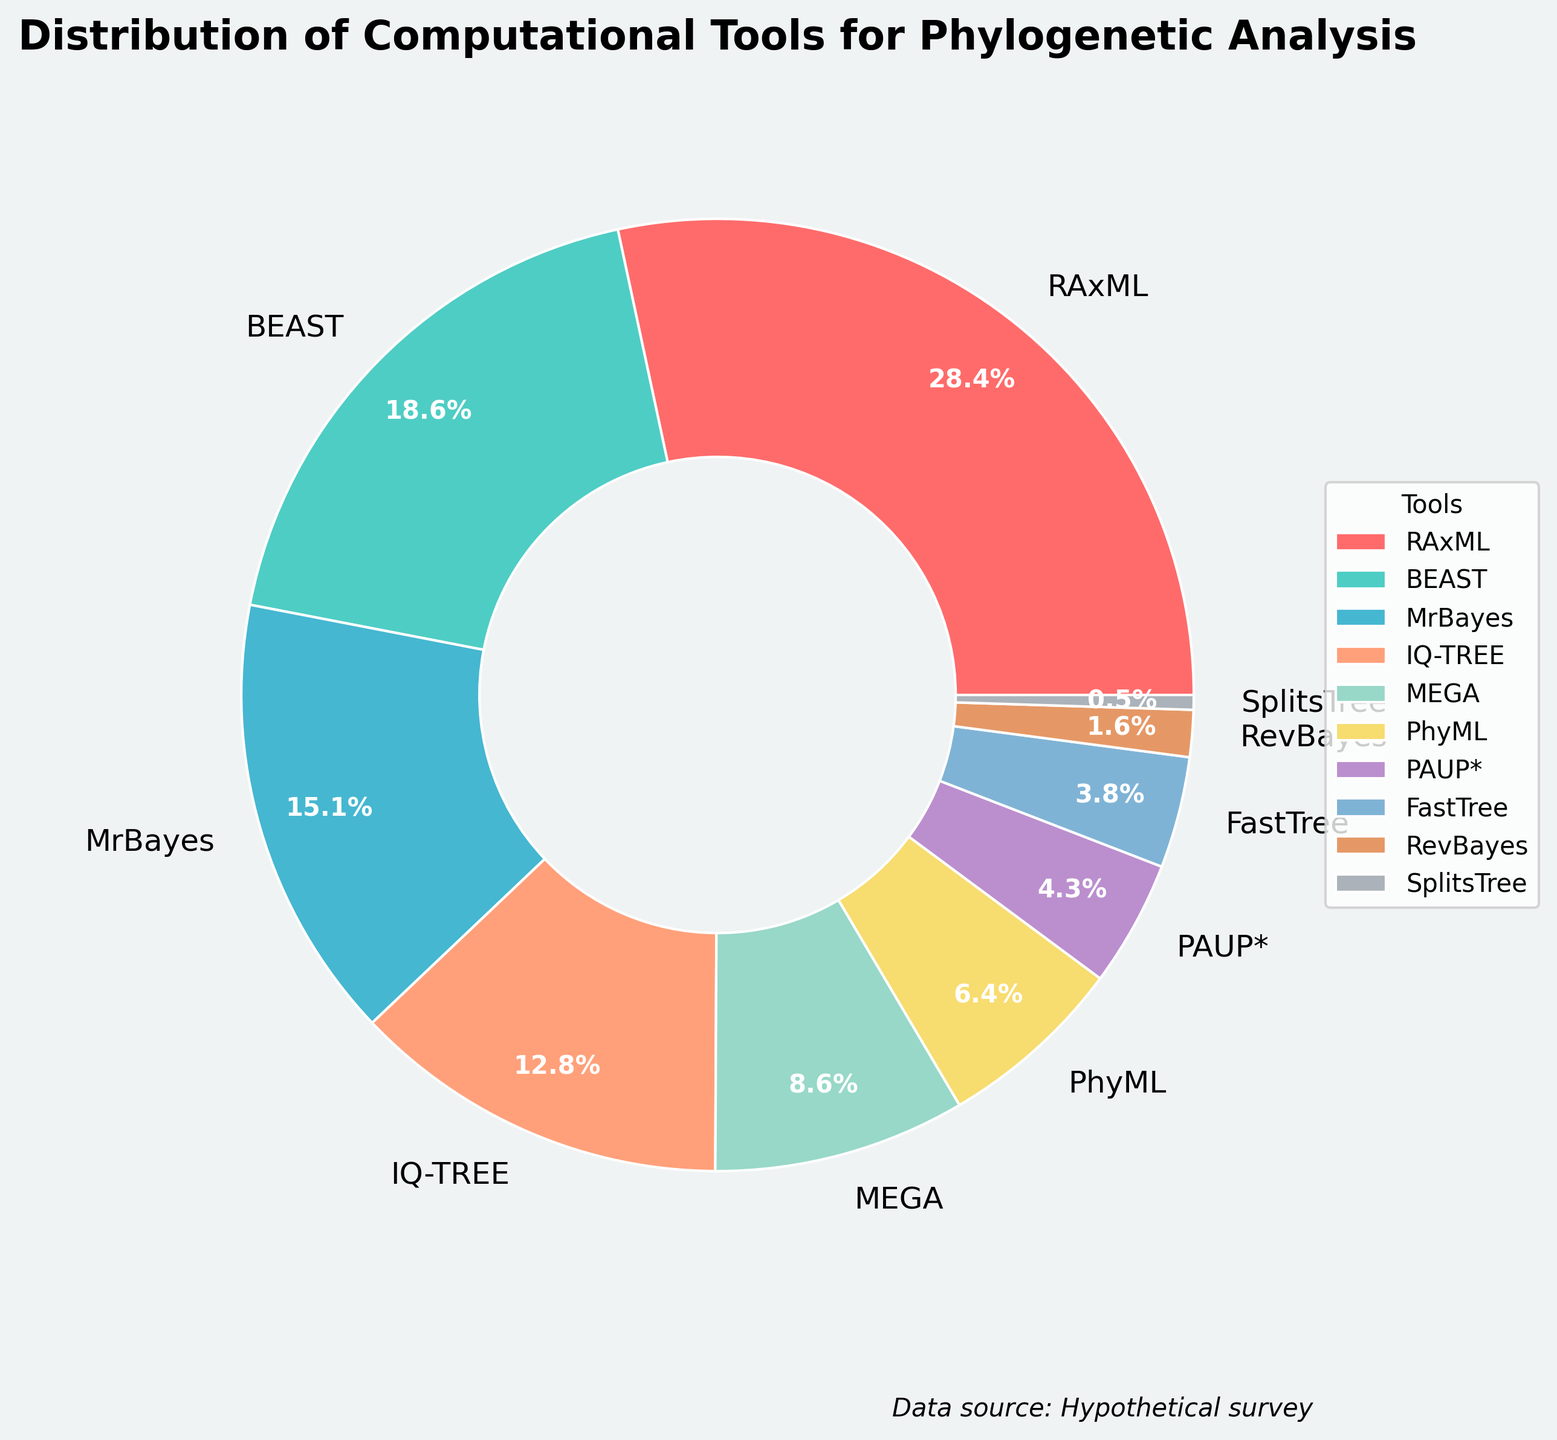Which tool has the highest usage percentage? The pie chart shows the usage percentages of different computational tools. By observing the largest section, we see that RAxML has the highest usage percentage.
Answer: RAxML What is the combined usage percentage of BEAST and MrBayes? We need to sum the usage percentages of BEAST and MrBayes. BEAST has 18.7% and MrBayes has 15.2%. Adding these together gives 18.7 + 15.2 = 33.9%.
Answer: 33.9% Which tool has the lowest usage percentage? The smallest section of the pie chart represents the tool with the lowest usage percentage. SplitsTree occupies the smallest section.
Answer: SplitsTree Are there any tools with similar usage percentages? By comparing the sections of the pie chart, we can see which tools have similar sizes. IQ-TREE and MEGA have similar usage percentages (12.9% and 8.6%, respectively), but upon closer inspection, they are not very close. PhyML and PAUP*, however, are closer (6.4% and 4.3%).
Answer: PhyML and PAUP* What is the difference in usage percentage between IQ-TREE and MEGA? We need to subtract the usage percentage of MEGA from that of IQ-TREE. IQ-TREE has 12.9% and MEGA has 8.6%. So, 12.9% - 8.6% = 4.3%.
Answer: 4.3% Between RAxML and FastTree, which tool is used less and by how much? RAxML has a usage percentage of 28.5% and FastTree has 3.8%. The difference is 28.5% - 3.8% = 24.7%.
Answer: FastTree by 24.7% Which tool is represented by the green color in the pie chart? Observing the pie chart, the tool associated with the green color section is BEAST.
Answer: BEAST How many tools have a usage percentage less than 5%? We need to count the tools with usage percentages below 5%. According to the chart, PAUP* (4.3%), FastTree (3.8%), RevBayes (1.6%), and SplitsTree (0.5%) fit this criterion.
Answer: 4 What is the average usage percentage of PhyML, PAUP*, and FastTree? To find the average, add the percentages of PhyML (6.4%), PAUP* (4.3%), and FastTree (3.8%) and divide by 3. The sum is 6.4 + 4.3 + 3.8 = 14.5. The average is 14.5 / 3 ≈ 4.83%.
Answer: ≈ 4.83% What is the total percentage of tools that have a usage percentage less than 10%? Sum the usage percentages of tools with less than 10% usage: MEGA (8.6%), PhyML (6.4%), PAUP* (4.3%), FastTree (3.8%), RevBayes (1.6%), SplitsTree (0.5%). The total is 8.6 + 6.4 + 4.3 + 3.8 + 1.6 + 0.5 = 25.2%.
Answer: 25.2% 